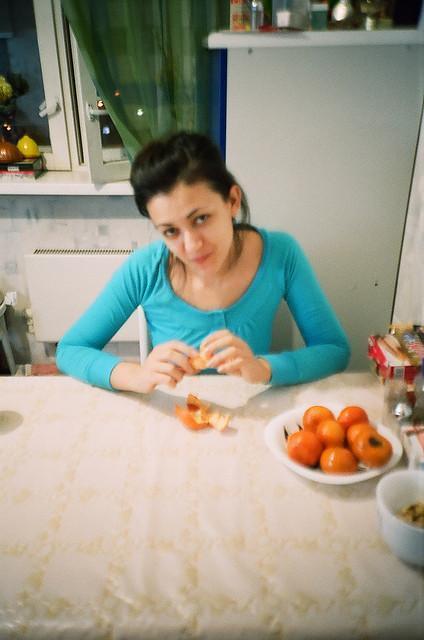How many bowls are in the picture?
Give a very brief answer. 2. How many skis are level against the snow?
Give a very brief answer. 0. 